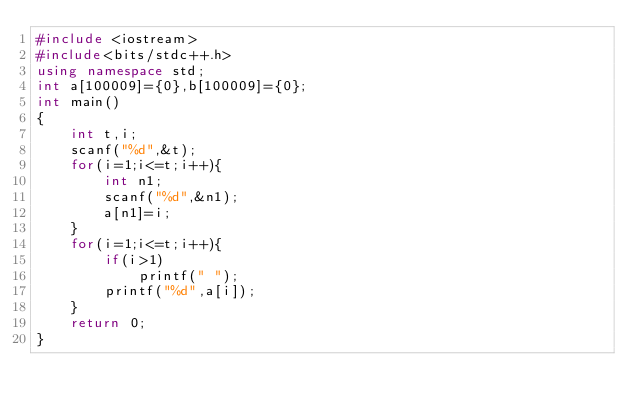<code> <loc_0><loc_0><loc_500><loc_500><_C++_>#include <iostream>
#include<bits/stdc++.h>
using namespace std;
int a[100009]={0},b[100009]={0};
int main()
{
    int t,i;
    scanf("%d",&t);
    for(i=1;i<=t;i++){
        int n1;
        scanf("%d",&n1);
        a[n1]=i;
    }
    for(i=1;i<=t;i++){
        if(i>1)
            printf(" ");
        printf("%d",a[i]);
    }
    return 0;
}
</code> 